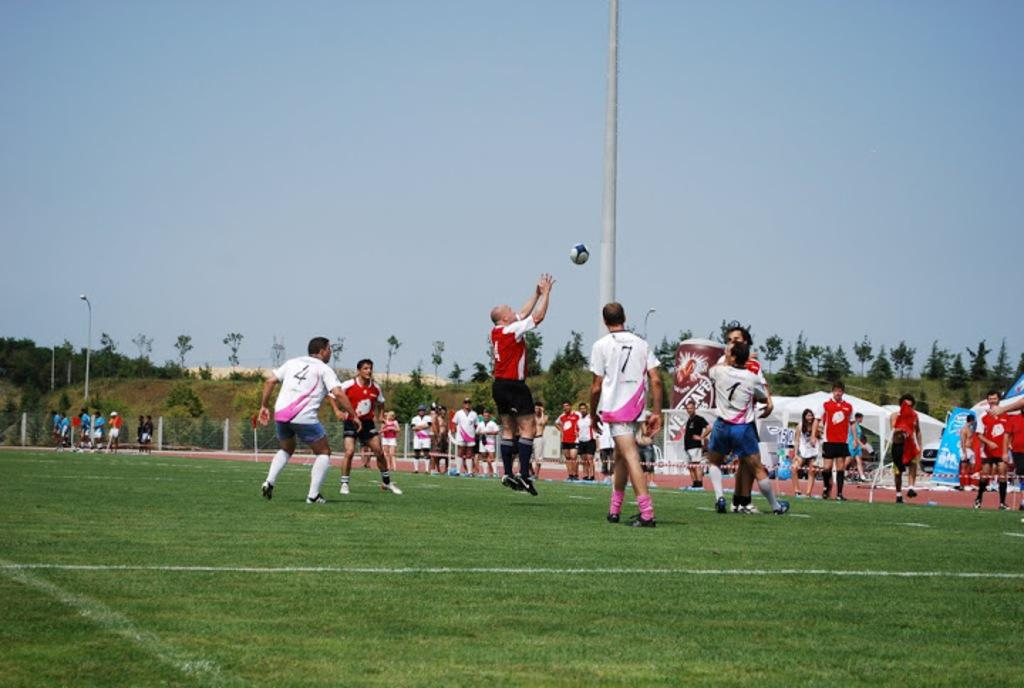<image>
Describe the image concisely. A man is playing soccer with a 7 on his back 